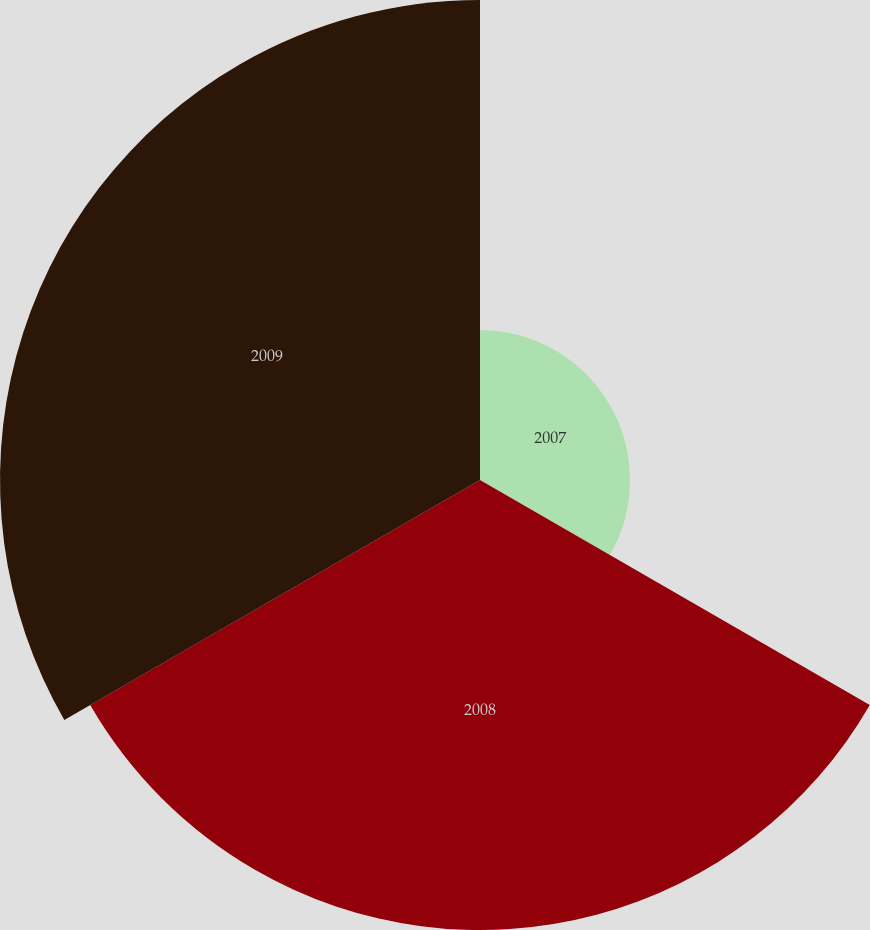<chart> <loc_0><loc_0><loc_500><loc_500><pie_chart><fcel>2007<fcel>2008<fcel>2009<nl><fcel>13.89%<fcel>41.67%<fcel>44.44%<nl></chart> 